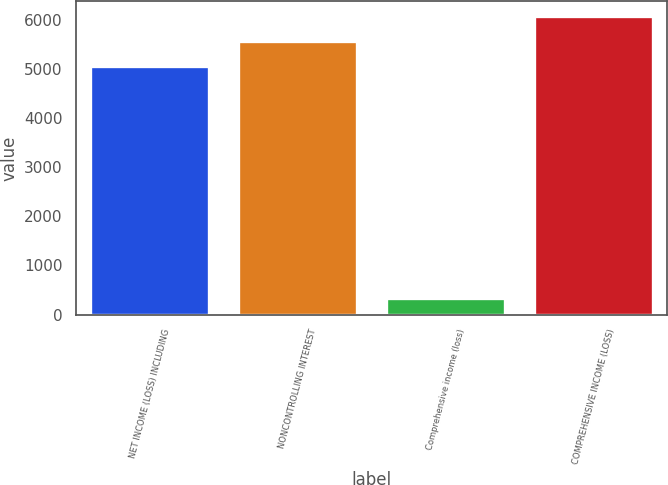Convert chart to OTSL. <chart><loc_0><loc_0><loc_500><loc_500><bar_chart><fcel>NET INCOME (LOSS) INCLUDING<fcel>NONCONTROLLING INTEREST<fcel>Comprehensive income (loss)<fcel>COMPREHENSIVE INCOME (LOSS)<nl><fcel>5060<fcel>5566.1<fcel>343<fcel>6072.2<nl></chart> 